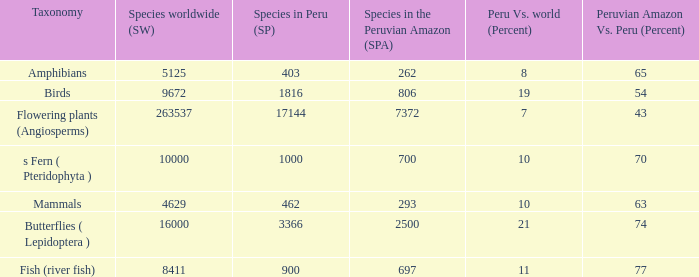What's the minimum species in the peruvian amazon with peru vs. world (percent) value of 7 7372.0. 